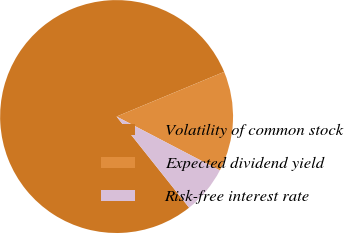<chart> <loc_0><loc_0><loc_500><loc_500><pie_chart><fcel>Volatility of common stock<fcel>Expected dividend yield<fcel>Risk-free interest rate<nl><fcel>79.44%<fcel>13.92%<fcel>6.65%<nl></chart> 